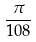<formula> <loc_0><loc_0><loc_500><loc_500>\frac { \pi } { 1 0 8 }</formula> 